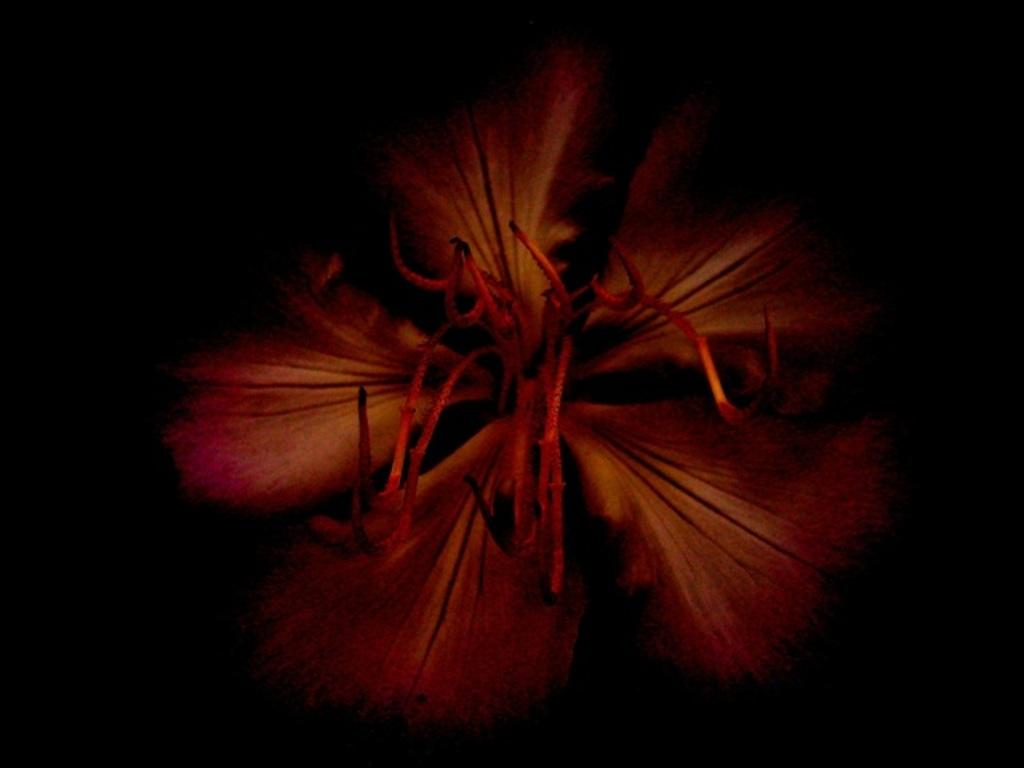What type of plant can be seen in the image? There is a flower in the image. What type of iron is used to make the zephyr in the image? There is no iron or zephyr present in the image; it features a flower. 